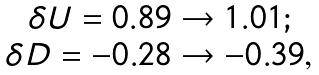Convert formula to latex. <formula><loc_0><loc_0><loc_500><loc_500>\begin{array} { c l c r } \delta U = 0 . 8 9 \to 1 . 0 1 ; \\ \delta D = - 0 . 2 8 \to - 0 . 3 9 , \end{array}</formula> 